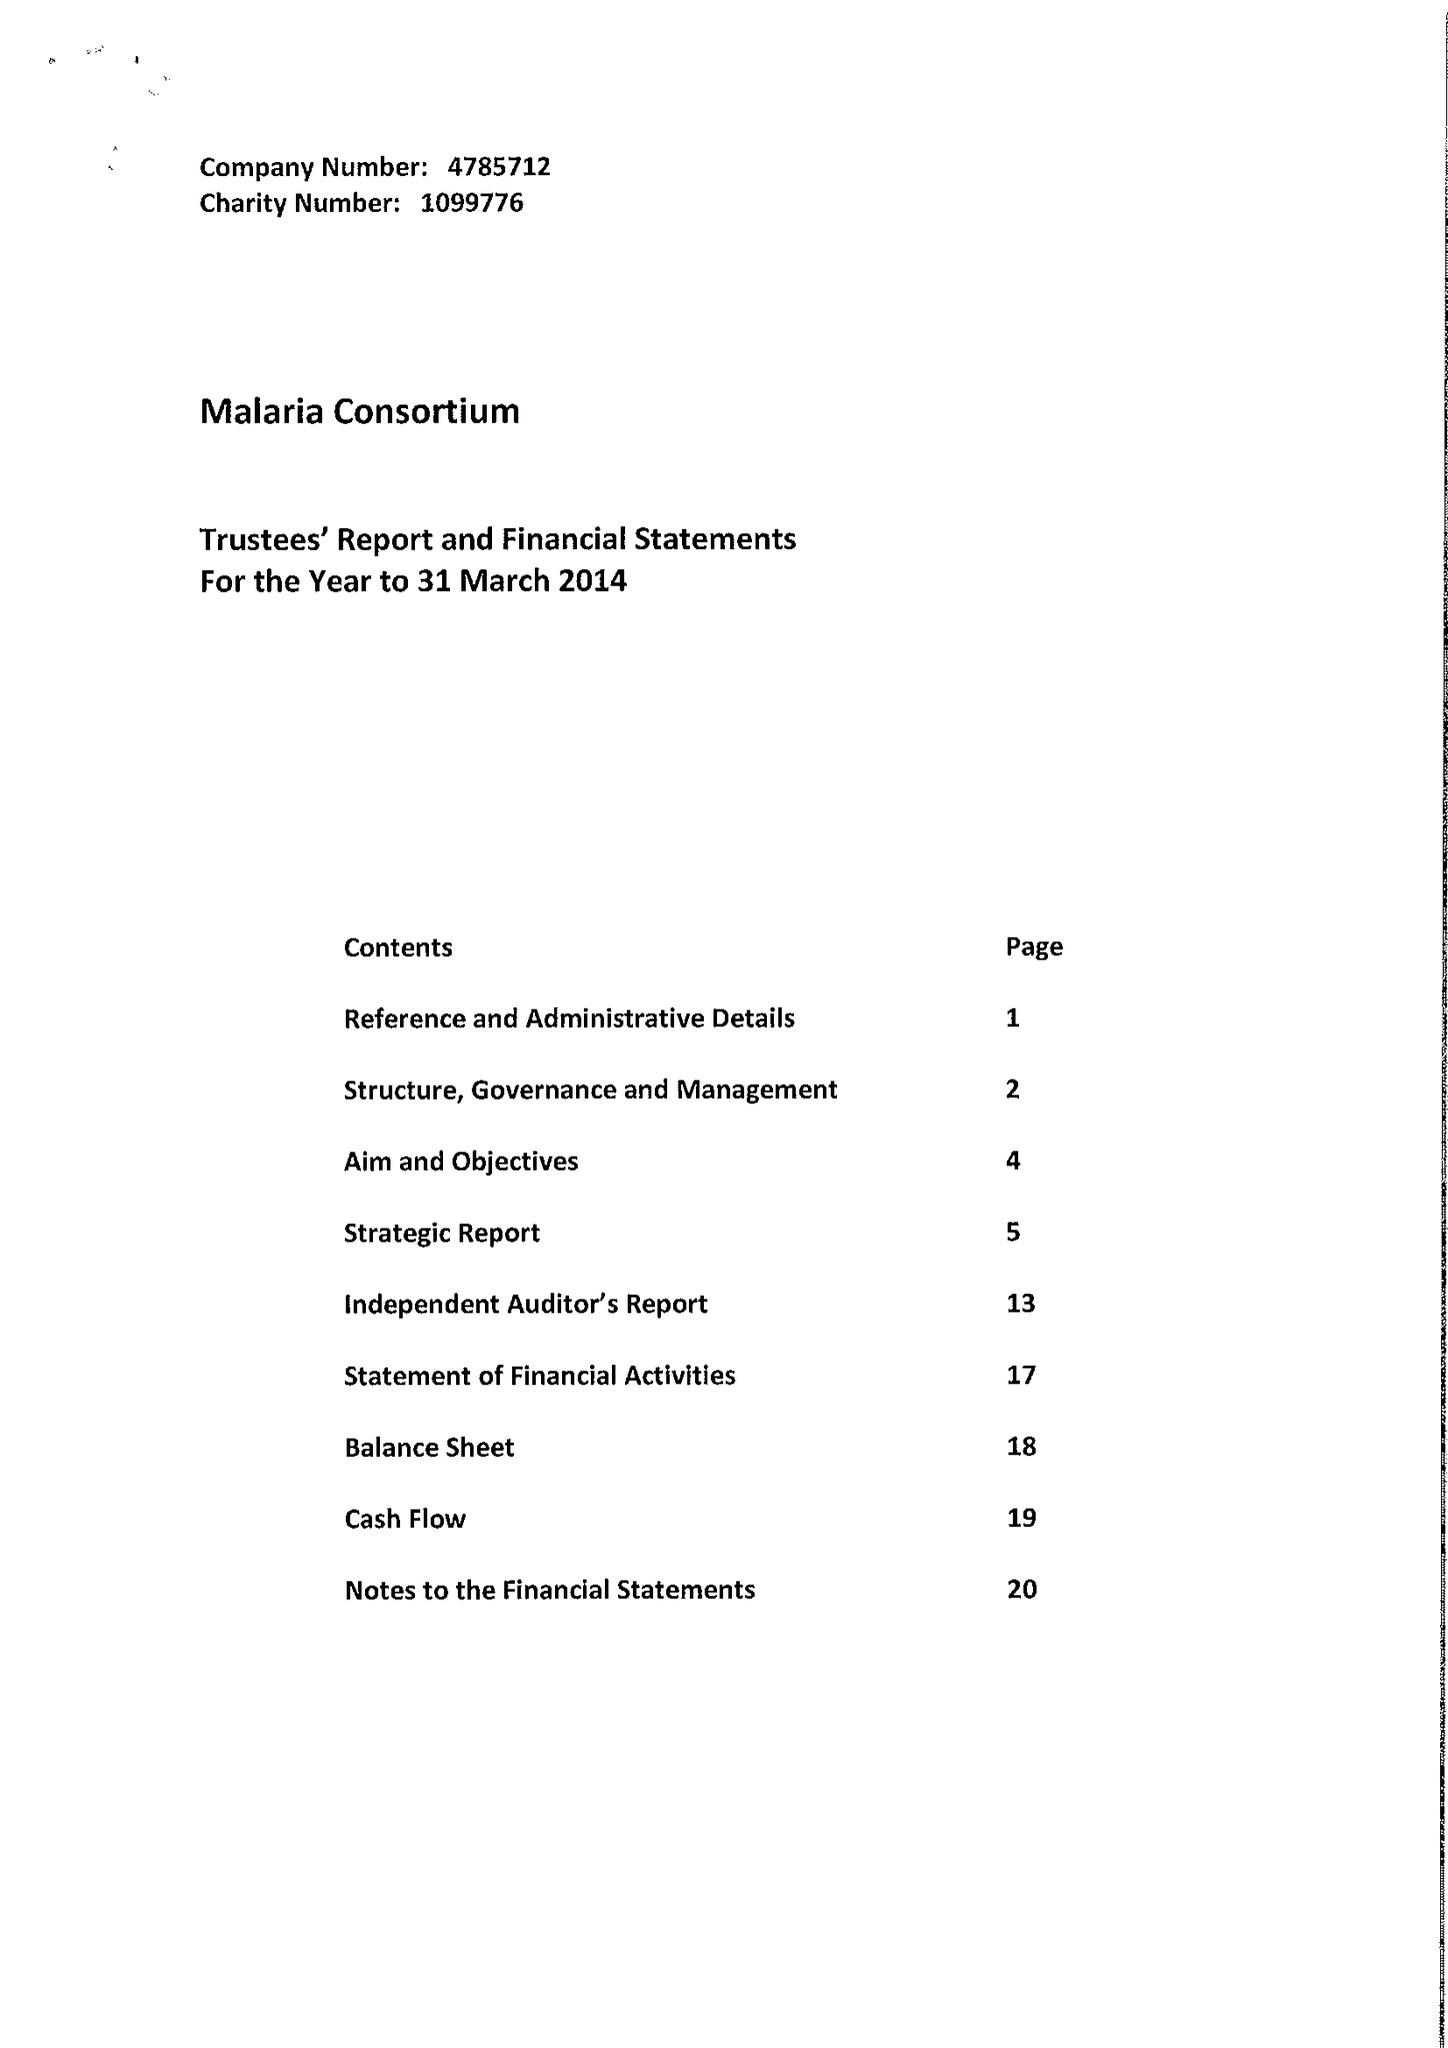What is the value for the income_annually_in_british_pounds?
Answer the question using a single word or phrase. 54534699.00 